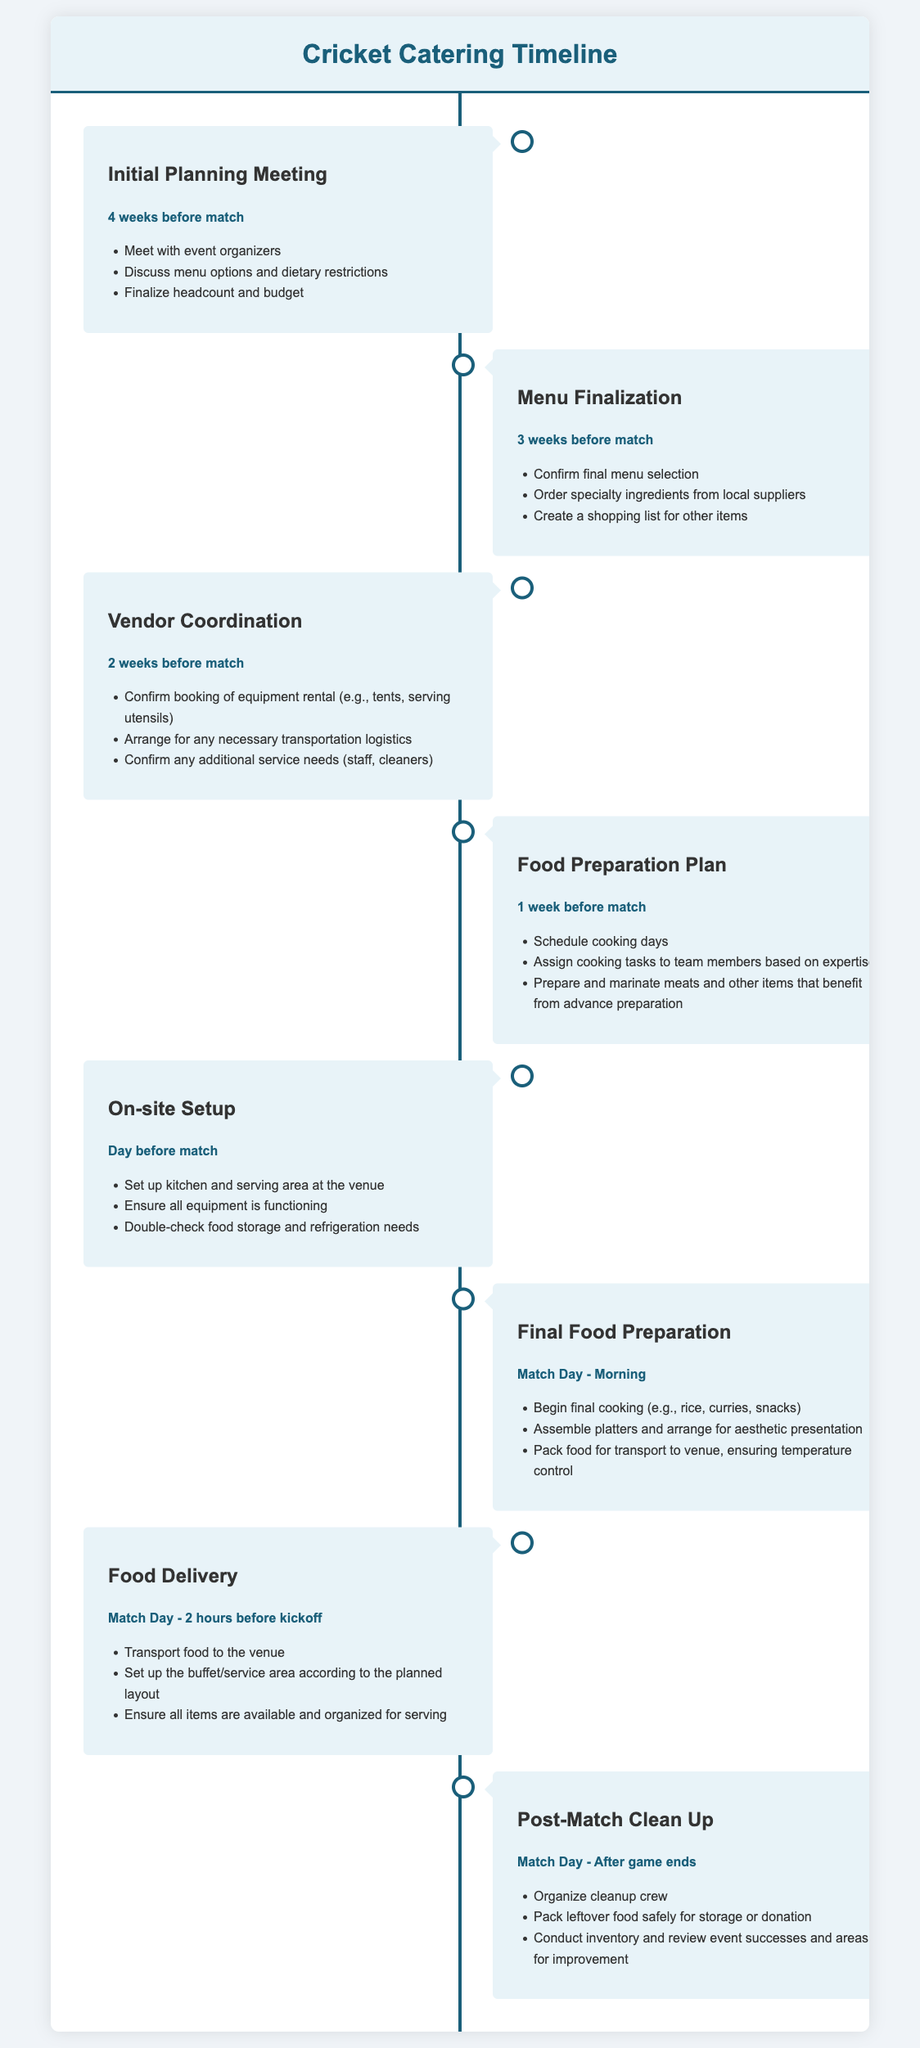What is the first milestone in the timeline? The first milestone listed is the "Initial Planning Meeting" which is detailed in the document.
Answer: Initial Planning Meeting How many weeks before the match is the Menu Finalization? The Menu Finalization is stated to occur three weeks before the match in the document.
Answer: 3 weeks What needs to be done two weeks before the match? The document lists specific responsibilities, such as confirming booking of equipment rental and arranging transportation logistics.
Answer: Vendor Coordination When does the final food preparation take place? The document specifies that the final food preparation begins in the morning on match day.
Answer: Match Day - Morning What is the date of the On-site Setup? According to the document, On-site Setup is scheduled for the day before the match.
Answer: Day before match What tasks are included in the Post-Match Clean Up? The document outlines a series of activities that include organizing cleanup crew and packing leftover food.
Answer: Organize cleanup crew Who is responsible for assigning cooking tasks? It indicates that team members will be assigned cooking tasks based on expertise during the food preparation plan.
Answer: Team members How long before kickoff does the food delivery occur? The food delivery is specified to happen 2 hours before kickoff in the timeline presented.
Answer: 2 hours before kickoff 